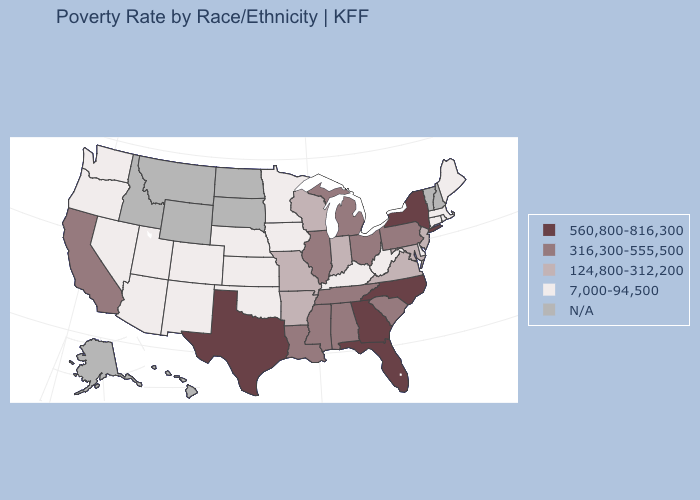Name the states that have a value in the range 124,800-312,200?
Be succinct. Arkansas, Indiana, Maryland, Missouri, New Jersey, Virginia, Wisconsin. Which states have the highest value in the USA?
Keep it brief. Florida, Georgia, New York, North Carolina, Texas. What is the highest value in the Northeast ?
Quick response, please. 560,800-816,300. Name the states that have a value in the range 124,800-312,200?
Keep it brief. Arkansas, Indiana, Maryland, Missouri, New Jersey, Virginia, Wisconsin. Name the states that have a value in the range N/A?
Quick response, please. Alaska, Hawaii, Idaho, Montana, New Hampshire, North Dakota, South Dakota, Vermont, Wyoming. Does the first symbol in the legend represent the smallest category?
Write a very short answer. No. Which states have the lowest value in the Northeast?
Be succinct. Connecticut, Maine, Massachusetts, Rhode Island. What is the value of Colorado?
Write a very short answer. 7,000-94,500. Which states have the lowest value in the USA?
Be succinct. Arizona, Colorado, Connecticut, Delaware, Iowa, Kansas, Kentucky, Maine, Massachusetts, Minnesota, Nebraska, Nevada, New Mexico, Oklahoma, Oregon, Rhode Island, Utah, Washington, West Virginia. How many symbols are there in the legend?
Quick response, please. 5. Name the states that have a value in the range 560,800-816,300?
Concise answer only. Florida, Georgia, New York, North Carolina, Texas. What is the value of California?
Answer briefly. 316,300-555,500. Name the states that have a value in the range 7,000-94,500?
Give a very brief answer. Arizona, Colorado, Connecticut, Delaware, Iowa, Kansas, Kentucky, Maine, Massachusetts, Minnesota, Nebraska, Nevada, New Mexico, Oklahoma, Oregon, Rhode Island, Utah, Washington, West Virginia. 